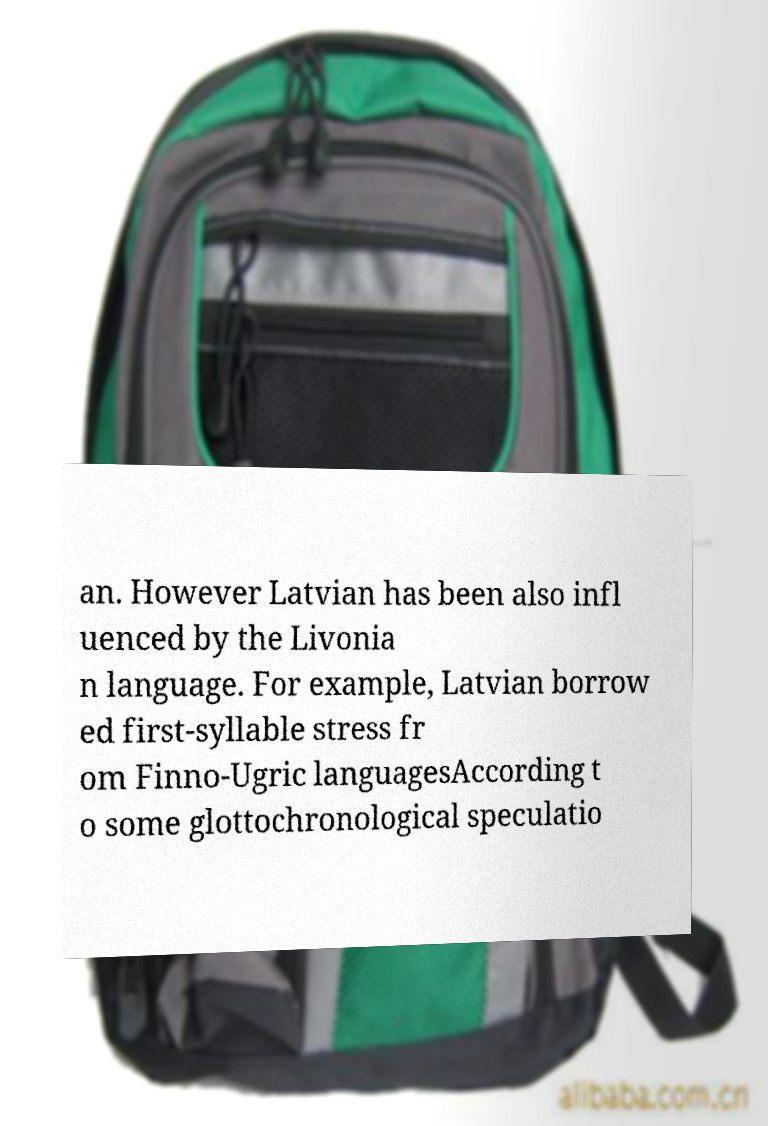Could you assist in decoding the text presented in this image and type it out clearly? an. However Latvian has been also infl uenced by the Livonia n language. For example, Latvian borrow ed first-syllable stress fr om Finno-Ugric languagesAccording t o some glottochronological speculatio 